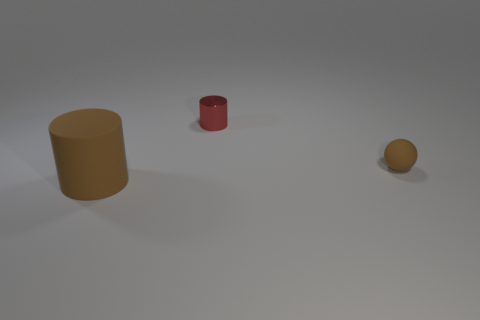Add 3 tiny brown things. How many objects exist? 6 Subtract all cylinders. How many objects are left? 1 Subtract 1 brown cylinders. How many objects are left? 2 Subtract all gray matte cylinders. Subtract all red metal objects. How many objects are left? 2 Add 1 large cylinders. How many large cylinders are left? 2 Add 1 small red metallic cylinders. How many small red metallic cylinders exist? 2 